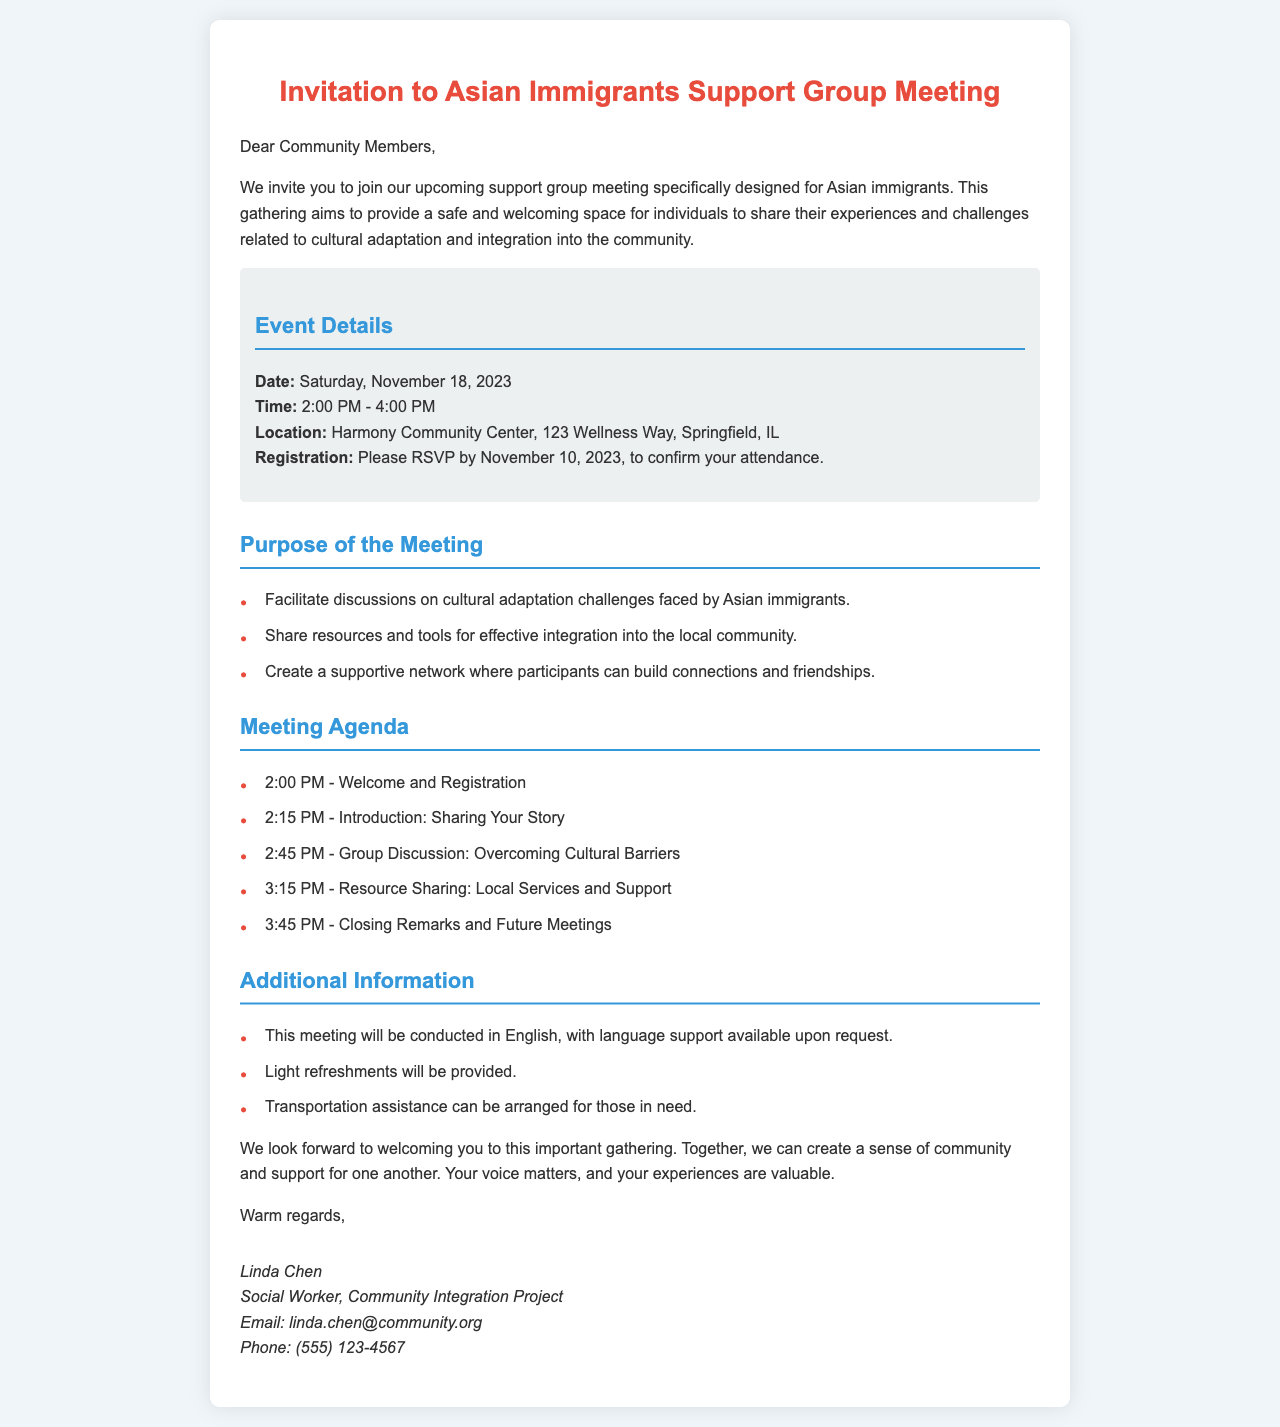What is the date of the meeting? The date of the meeting is specified in the document as Saturday, November 18, 2023.
Answer: Saturday, November 18, 2023 What time does the support group meeting start? The document states that the meeting starts at 2:00 PM.
Answer: 2:00 PM Where is the location of the meeting? The location provided is Harmony Community Center, 123 Wellness Way, Springfield, IL.
Answer: Harmony Community Center, 123 Wellness Way, Springfield, IL What will be discussed regarding cultural adaptation? The document outlines discussions on cultural adaptation challenges faced by Asian immigrants.
Answer: Cultural adaptation challenges What is required to confirm attendance? The document mentions that participants need to RSVP by November 10, 2023, to confirm attendance.
Answer: RSVP by November 10, 2023 What type of support is available for the meeting? The document indicates that language support is available upon request.
Answer: Language support upon request Who is the organizer of the support group? The organizer's name, as stated in the document, is Linda Chen.
Answer: Linda Chen What is the purpose of the gathering? The main purpose includes providing a safe space for sharing experiences and challenges related to cultural adaptation and integration.
Answer: Safe space for sharing experiences What refreshments will be provided at the meeting? The document notes that light refreshments will be provided at the meeting.
Answer: Light refreshments How long is the meeting scheduled to last? The document states that the meeting is scheduled from 2:00 PM to 4:00 PM, lasting a total of 2 hours.
Answer: 2 hours 